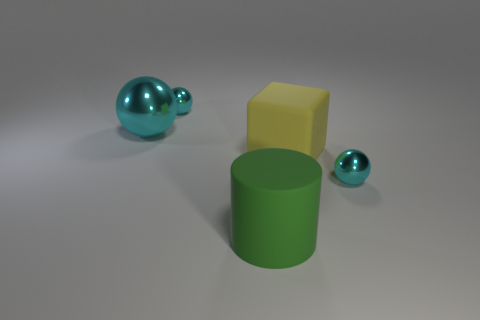Subtract all cyan spheres. How many were subtracted if there are1cyan spheres left? 2 Subtract all small metallic spheres. How many spheres are left? 1 Subtract all blocks. How many objects are left? 4 Subtract 3 balls. How many balls are left? 0 Add 5 large cyan metallic things. How many large cyan metallic things exist? 6 Add 3 tiny shiny spheres. How many objects exist? 8 Subtract 0 red balls. How many objects are left? 5 Subtract all red spheres. Subtract all gray blocks. How many spheres are left? 3 Subtract all tiny cyan rubber cubes. Subtract all metallic balls. How many objects are left? 2 Add 2 small cyan objects. How many small cyan objects are left? 4 